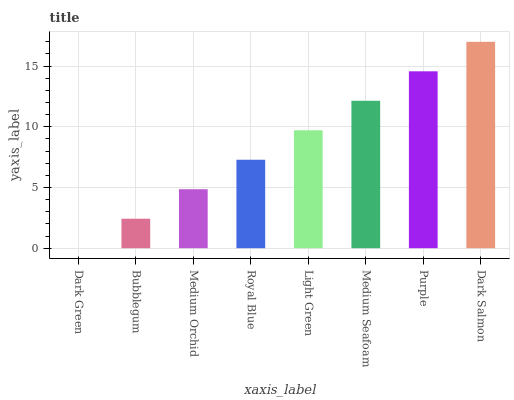Is Dark Green the minimum?
Answer yes or no. Yes. Is Dark Salmon the maximum?
Answer yes or no. Yes. Is Bubblegum the minimum?
Answer yes or no. No. Is Bubblegum the maximum?
Answer yes or no. No. Is Bubblegum greater than Dark Green?
Answer yes or no. Yes. Is Dark Green less than Bubblegum?
Answer yes or no. Yes. Is Dark Green greater than Bubblegum?
Answer yes or no. No. Is Bubblegum less than Dark Green?
Answer yes or no. No. Is Light Green the high median?
Answer yes or no. Yes. Is Royal Blue the low median?
Answer yes or no. Yes. Is Medium Orchid the high median?
Answer yes or no. No. Is Light Green the low median?
Answer yes or no. No. 